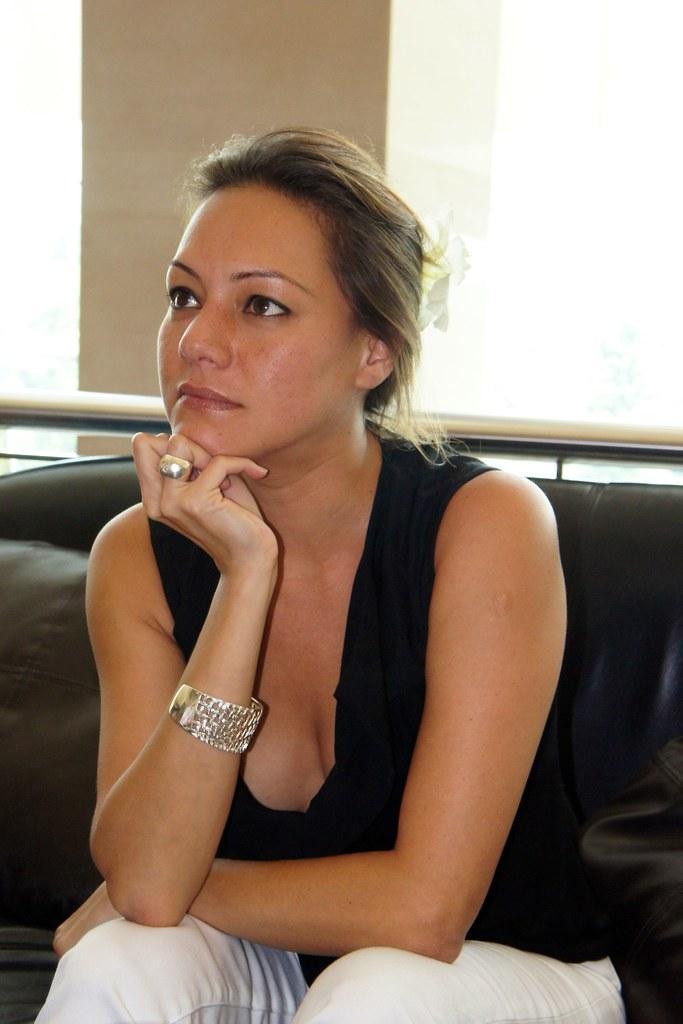Can you describe this image briefly? In the picture I can see a woman sitting on a sofa and she is in the middle of the image. She is wearing a black color top and a white pant. I can see a bangle on her right hand and a ring on her finger. I can see a stainless steel pole. This is looking like a pillar at the top of the image. 